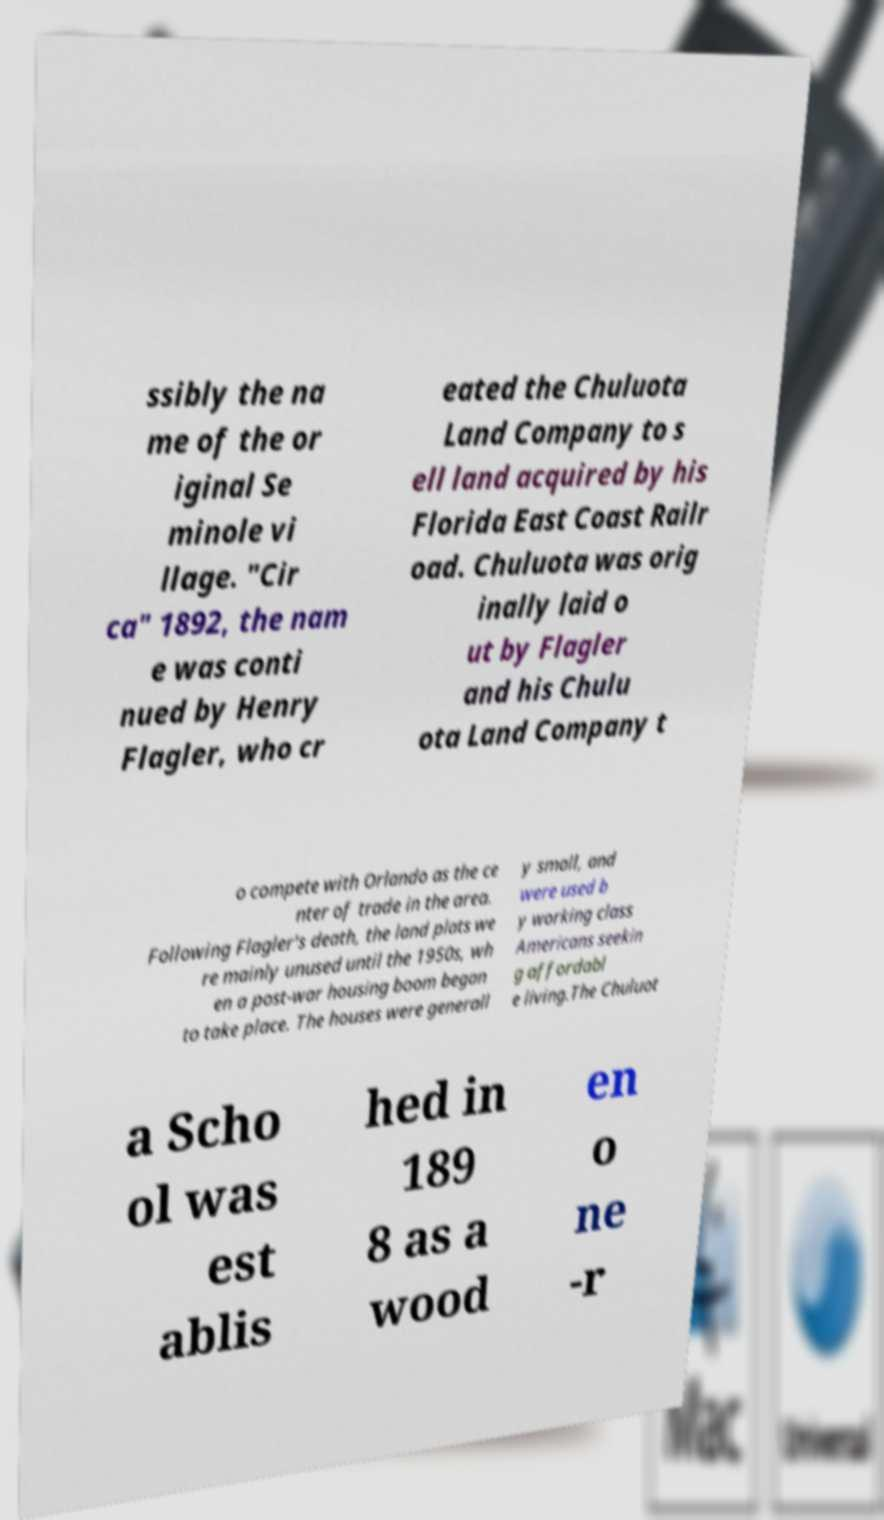I need the written content from this picture converted into text. Can you do that? ssibly the na me of the or iginal Se minole vi llage. "Cir ca" 1892, the nam e was conti nued by Henry Flagler, who cr eated the Chuluota Land Company to s ell land acquired by his Florida East Coast Railr oad. Chuluota was orig inally laid o ut by Flagler and his Chulu ota Land Company t o compete with Orlando as the ce nter of trade in the area. Following Flagler's death, the land plats we re mainly unused until the 1950s, wh en a post-war housing boom began to take place. The houses were generall y small, and were used b y working class Americans seekin g affordabl e living.The Chuluot a Scho ol was est ablis hed in 189 8 as a wood en o ne -r 